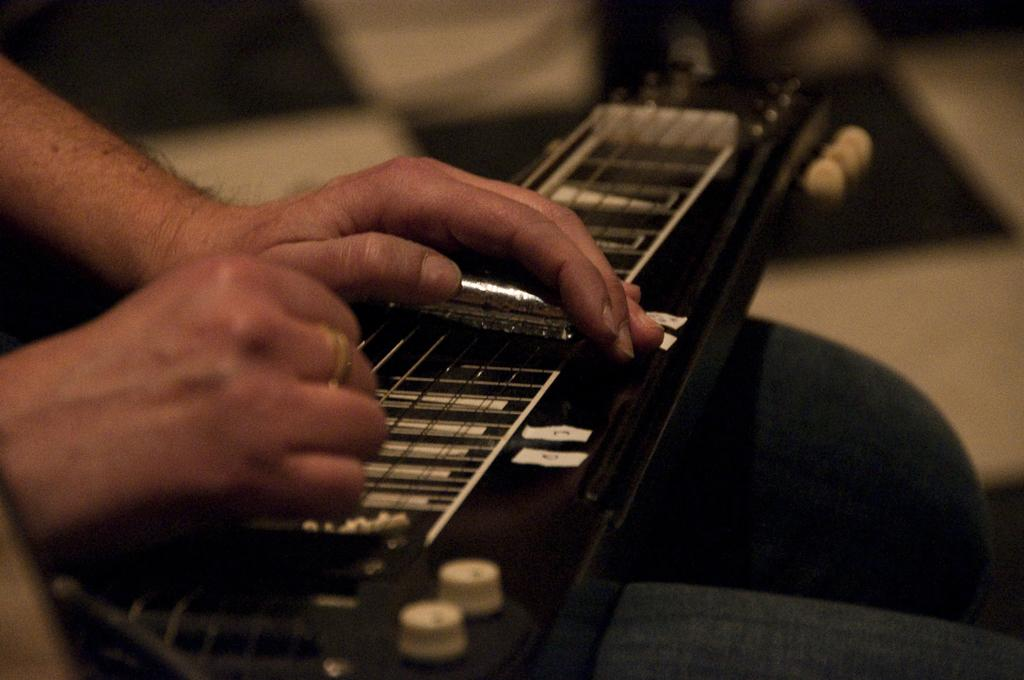What body part is visible in the image? Human hands are visible in the image. What is the hands resting on? A lap is visible in the image. What object is placed on the lap? There is a musical instrument placed on the lap. What colors are present at the top of the image? There are white and black colors at the top of the image. What type of lead is being used to create a patch on the border in the image? There is no lead, patch, or border present in the image. 